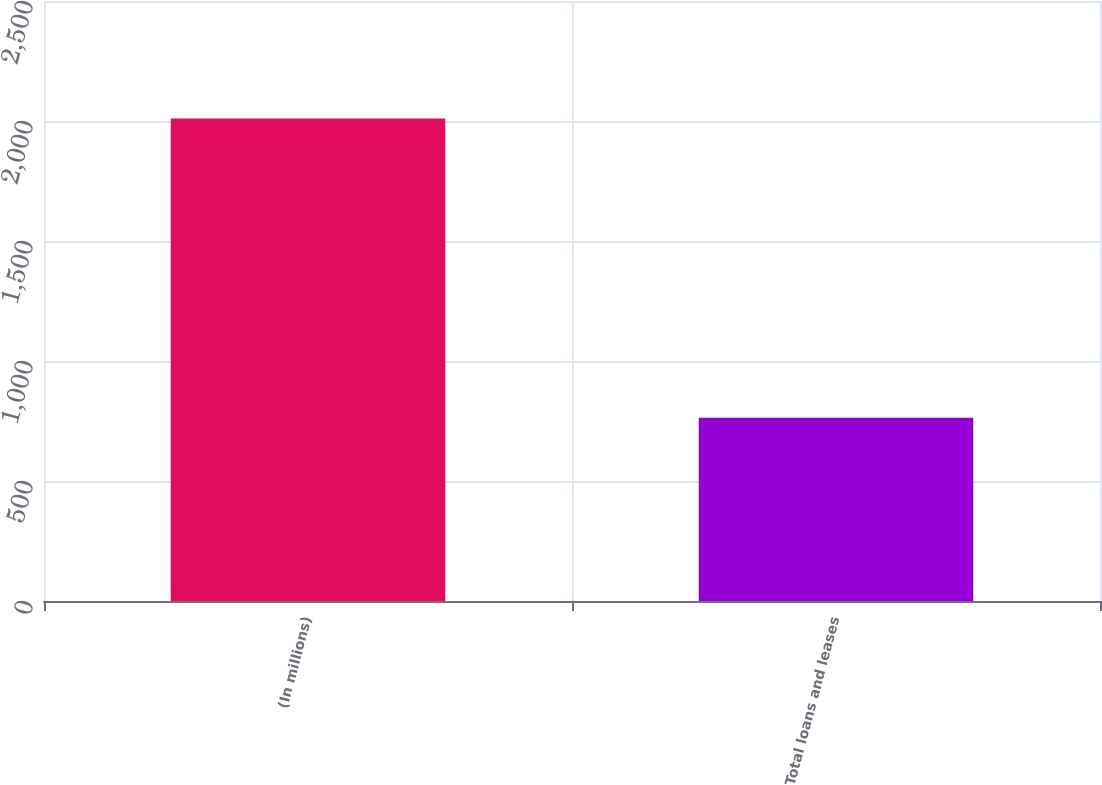Convert chart to OTSL. <chart><loc_0><loc_0><loc_500><loc_500><bar_chart><fcel>(In millions)<fcel>Total loans and leases<nl><fcel>2010<fcel>764<nl></chart> 